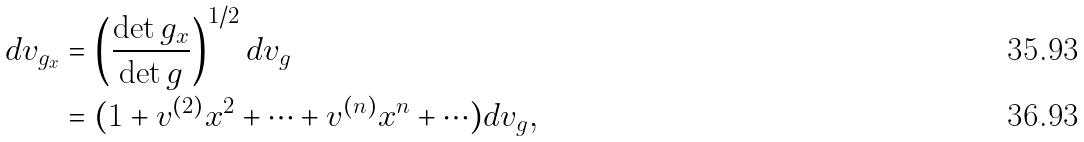<formula> <loc_0><loc_0><loc_500><loc_500>d v _ { g _ { x } } & = \left ( \frac { \det g _ { x } } { \det g } \right ) ^ { 1 / 2 } d v _ { g } \\ & = ( 1 + v ^ { ( 2 ) } x ^ { 2 } + \cdots + v ^ { ( n ) } x ^ { n } + \cdots ) d v _ { g } ,</formula> 